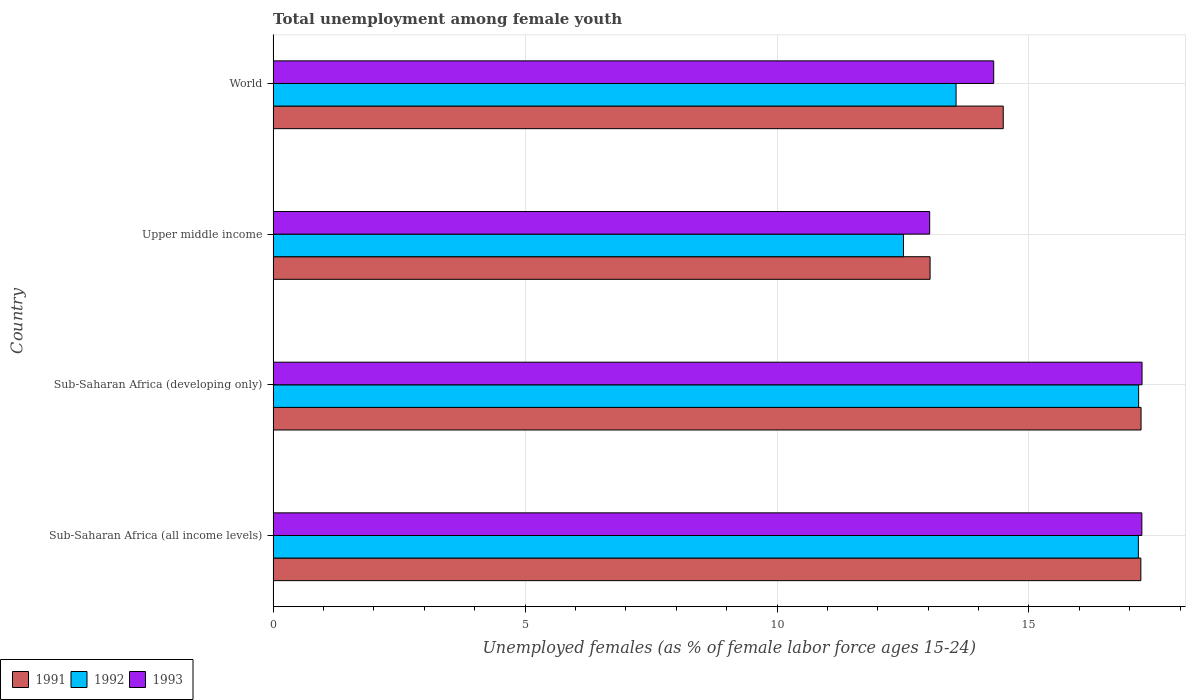How many bars are there on the 2nd tick from the bottom?
Keep it short and to the point. 3. What is the label of the 4th group of bars from the top?
Provide a short and direct response. Sub-Saharan Africa (all income levels). In how many cases, is the number of bars for a given country not equal to the number of legend labels?
Provide a short and direct response. 0. What is the percentage of unemployed females in in 1993 in Upper middle income?
Your answer should be compact. 13.03. Across all countries, what is the maximum percentage of unemployed females in in 1993?
Make the answer very short. 17.24. Across all countries, what is the minimum percentage of unemployed females in in 1991?
Provide a short and direct response. 13.04. In which country was the percentage of unemployed females in in 1993 maximum?
Offer a terse response. Sub-Saharan Africa (developing only). In which country was the percentage of unemployed females in in 1993 minimum?
Make the answer very short. Upper middle income. What is the total percentage of unemployed females in in 1993 in the graph?
Give a very brief answer. 61.81. What is the difference between the percentage of unemployed females in in 1991 in Sub-Saharan Africa (developing only) and that in Upper middle income?
Provide a short and direct response. 4.19. What is the difference between the percentage of unemployed females in in 1992 in Sub-Saharan Africa (developing only) and the percentage of unemployed females in in 1991 in World?
Keep it short and to the point. 2.69. What is the average percentage of unemployed females in in 1991 per country?
Make the answer very short. 15.49. What is the difference between the percentage of unemployed females in in 1993 and percentage of unemployed females in in 1991 in World?
Ensure brevity in your answer.  -0.19. In how many countries, is the percentage of unemployed females in in 1991 greater than 12 %?
Your response must be concise. 4. What is the ratio of the percentage of unemployed females in in 1991 in Sub-Saharan Africa (all income levels) to that in Sub-Saharan Africa (developing only)?
Your answer should be compact. 1. Is the difference between the percentage of unemployed females in in 1993 in Sub-Saharan Africa (developing only) and Upper middle income greater than the difference between the percentage of unemployed females in in 1991 in Sub-Saharan Africa (developing only) and Upper middle income?
Offer a very short reply. Yes. What is the difference between the highest and the second highest percentage of unemployed females in in 1992?
Your answer should be very brief. 0.01. What is the difference between the highest and the lowest percentage of unemployed females in in 1991?
Provide a succinct answer. 4.19. In how many countries, is the percentage of unemployed females in in 1991 greater than the average percentage of unemployed females in in 1991 taken over all countries?
Offer a very short reply. 2. Is the sum of the percentage of unemployed females in in 1992 in Sub-Saharan Africa (developing only) and World greater than the maximum percentage of unemployed females in in 1991 across all countries?
Your answer should be compact. Yes. What does the 1st bar from the bottom in Sub-Saharan Africa (developing only) represents?
Your response must be concise. 1991. Is it the case that in every country, the sum of the percentage of unemployed females in in 1992 and percentage of unemployed females in in 1993 is greater than the percentage of unemployed females in in 1991?
Make the answer very short. Yes. How many bars are there?
Provide a succinct answer. 12. Are all the bars in the graph horizontal?
Provide a succinct answer. Yes. Does the graph contain grids?
Provide a short and direct response. Yes. Where does the legend appear in the graph?
Your answer should be compact. Bottom left. What is the title of the graph?
Ensure brevity in your answer.  Total unemployment among female youth. What is the label or title of the X-axis?
Ensure brevity in your answer.  Unemployed females (as % of female labor force ages 15-24). What is the Unemployed females (as % of female labor force ages 15-24) of 1991 in Sub-Saharan Africa (all income levels)?
Keep it short and to the point. 17.22. What is the Unemployed females (as % of female labor force ages 15-24) of 1992 in Sub-Saharan Africa (all income levels)?
Offer a terse response. 17.17. What is the Unemployed females (as % of female labor force ages 15-24) in 1993 in Sub-Saharan Africa (all income levels)?
Your response must be concise. 17.24. What is the Unemployed females (as % of female labor force ages 15-24) in 1991 in Sub-Saharan Africa (developing only)?
Provide a short and direct response. 17.22. What is the Unemployed females (as % of female labor force ages 15-24) in 1992 in Sub-Saharan Africa (developing only)?
Make the answer very short. 17.18. What is the Unemployed females (as % of female labor force ages 15-24) of 1993 in Sub-Saharan Africa (developing only)?
Provide a succinct answer. 17.24. What is the Unemployed females (as % of female labor force ages 15-24) of 1991 in Upper middle income?
Provide a short and direct response. 13.04. What is the Unemployed females (as % of female labor force ages 15-24) of 1992 in Upper middle income?
Keep it short and to the point. 12.51. What is the Unemployed females (as % of female labor force ages 15-24) of 1993 in Upper middle income?
Make the answer very short. 13.03. What is the Unemployed females (as % of female labor force ages 15-24) in 1991 in World?
Give a very brief answer. 14.49. What is the Unemployed females (as % of female labor force ages 15-24) in 1992 in World?
Provide a succinct answer. 13.55. What is the Unemployed females (as % of female labor force ages 15-24) of 1993 in World?
Make the answer very short. 14.3. Across all countries, what is the maximum Unemployed females (as % of female labor force ages 15-24) in 1991?
Your answer should be very brief. 17.22. Across all countries, what is the maximum Unemployed females (as % of female labor force ages 15-24) of 1992?
Provide a short and direct response. 17.18. Across all countries, what is the maximum Unemployed females (as % of female labor force ages 15-24) of 1993?
Your response must be concise. 17.24. Across all countries, what is the minimum Unemployed females (as % of female labor force ages 15-24) in 1991?
Your answer should be compact. 13.04. Across all countries, what is the minimum Unemployed females (as % of female labor force ages 15-24) of 1992?
Your answer should be very brief. 12.51. Across all countries, what is the minimum Unemployed females (as % of female labor force ages 15-24) in 1993?
Ensure brevity in your answer.  13.03. What is the total Unemployed females (as % of female labor force ages 15-24) in 1991 in the graph?
Offer a very short reply. 61.97. What is the total Unemployed females (as % of female labor force ages 15-24) in 1992 in the graph?
Provide a short and direct response. 60.41. What is the total Unemployed females (as % of female labor force ages 15-24) in 1993 in the graph?
Your answer should be very brief. 61.81. What is the difference between the Unemployed females (as % of female labor force ages 15-24) of 1991 in Sub-Saharan Africa (all income levels) and that in Sub-Saharan Africa (developing only)?
Give a very brief answer. -0. What is the difference between the Unemployed females (as % of female labor force ages 15-24) in 1992 in Sub-Saharan Africa (all income levels) and that in Sub-Saharan Africa (developing only)?
Your answer should be compact. -0.01. What is the difference between the Unemployed females (as % of female labor force ages 15-24) in 1993 in Sub-Saharan Africa (all income levels) and that in Sub-Saharan Africa (developing only)?
Offer a very short reply. -0. What is the difference between the Unemployed females (as % of female labor force ages 15-24) of 1991 in Sub-Saharan Africa (all income levels) and that in Upper middle income?
Provide a short and direct response. 4.18. What is the difference between the Unemployed females (as % of female labor force ages 15-24) of 1992 in Sub-Saharan Africa (all income levels) and that in Upper middle income?
Provide a short and direct response. 4.66. What is the difference between the Unemployed females (as % of female labor force ages 15-24) of 1993 in Sub-Saharan Africa (all income levels) and that in Upper middle income?
Provide a succinct answer. 4.21. What is the difference between the Unemployed females (as % of female labor force ages 15-24) in 1991 in Sub-Saharan Africa (all income levels) and that in World?
Offer a very short reply. 2.73. What is the difference between the Unemployed females (as % of female labor force ages 15-24) of 1992 in Sub-Saharan Africa (all income levels) and that in World?
Your answer should be very brief. 3.62. What is the difference between the Unemployed females (as % of female labor force ages 15-24) in 1993 in Sub-Saharan Africa (all income levels) and that in World?
Offer a very short reply. 2.94. What is the difference between the Unemployed females (as % of female labor force ages 15-24) in 1991 in Sub-Saharan Africa (developing only) and that in Upper middle income?
Provide a succinct answer. 4.19. What is the difference between the Unemployed females (as % of female labor force ages 15-24) in 1992 in Sub-Saharan Africa (developing only) and that in Upper middle income?
Provide a short and direct response. 4.67. What is the difference between the Unemployed females (as % of female labor force ages 15-24) in 1993 in Sub-Saharan Africa (developing only) and that in Upper middle income?
Provide a succinct answer. 4.21. What is the difference between the Unemployed females (as % of female labor force ages 15-24) in 1991 in Sub-Saharan Africa (developing only) and that in World?
Your answer should be compact. 2.73. What is the difference between the Unemployed females (as % of female labor force ages 15-24) in 1992 in Sub-Saharan Africa (developing only) and that in World?
Your response must be concise. 3.62. What is the difference between the Unemployed females (as % of female labor force ages 15-24) in 1993 in Sub-Saharan Africa (developing only) and that in World?
Your response must be concise. 2.94. What is the difference between the Unemployed females (as % of female labor force ages 15-24) in 1991 in Upper middle income and that in World?
Your response must be concise. -1.45. What is the difference between the Unemployed females (as % of female labor force ages 15-24) of 1992 in Upper middle income and that in World?
Keep it short and to the point. -1.04. What is the difference between the Unemployed females (as % of female labor force ages 15-24) of 1993 in Upper middle income and that in World?
Ensure brevity in your answer.  -1.27. What is the difference between the Unemployed females (as % of female labor force ages 15-24) of 1991 in Sub-Saharan Africa (all income levels) and the Unemployed females (as % of female labor force ages 15-24) of 1992 in Sub-Saharan Africa (developing only)?
Make the answer very short. 0.04. What is the difference between the Unemployed females (as % of female labor force ages 15-24) in 1991 in Sub-Saharan Africa (all income levels) and the Unemployed females (as % of female labor force ages 15-24) in 1993 in Sub-Saharan Africa (developing only)?
Give a very brief answer. -0.02. What is the difference between the Unemployed females (as % of female labor force ages 15-24) of 1992 in Sub-Saharan Africa (all income levels) and the Unemployed females (as % of female labor force ages 15-24) of 1993 in Sub-Saharan Africa (developing only)?
Your answer should be very brief. -0.07. What is the difference between the Unemployed females (as % of female labor force ages 15-24) in 1991 in Sub-Saharan Africa (all income levels) and the Unemployed females (as % of female labor force ages 15-24) in 1992 in Upper middle income?
Keep it short and to the point. 4.71. What is the difference between the Unemployed females (as % of female labor force ages 15-24) of 1991 in Sub-Saharan Africa (all income levels) and the Unemployed females (as % of female labor force ages 15-24) of 1993 in Upper middle income?
Provide a short and direct response. 4.19. What is the difference between the Unemployed females (as % of female labor force ages 15-24) of 1992 in Sub-Saharan Africa (all income levels) and the Unemployed females (as % of female labor force ages 15-24) of 1993 in Upper middle income?
Your answer should be compact. 4.14. What is the difference between the Unemployed females (as % of female labor force ages 15-24) in 1991 in Sub-Saharan Africa (all income levels) and the Unemployed females (as % of female labor force ages 15-24) in 1992 in World?
Provide a succinct answer. 3.67. What is the difference between the Unemployed females (as % of female labor force ages 15-24) of 1991 in Sub-Saharan Africa (all income levels) and the Unemployed females (as % of female labor force ages 15-24) of 1993 in World?
Your answer should be very brief. 2.92. What is the difference between the Unemployed females (as % of female labor force ages 15-24) of 1992 in Sub-Saharan Africa (all income levels) and the Unemployed females (as % of female labor force ages 15-24) of 1993 in World?
Offer a very short reply. 2.87. What is the difference between the Unemployed females (as % of female labor force ages 15-24) in 1991 in Sub-Saharan Africa (developing only) and the Unemployed females (as % of female labor force ages 15-24) in 1992 in Upper middle income?
Provide a short and direct response. 4.71. What is the difference between the Unemployed females (as % of female labor force ages 15-24) in 1991 in Sub-Saharan Africa (developing only) and the Unemployed females (as % of female labor force ages 15-24) in 1993 in Upper middle income?
Offer a very short reply. 4.19. What is the difference between the Unemployed females (as % of female labor force ages 15-24) of 1992 in Sub-Saharan Africa (developing only) and the Unemployed females (as % of female labor force ages 15-24) of 1993 in Upper middle income?
Your response must be concise. 4.15. What is the difference between the Unemployed females (as % of female labor force ages 15-24) of 1991 in Sub-Saharan Africa (developing only) and the Unemployed females (as % of female labor force ages 15-24) of 1992 in World?
Offer a terse response. 3.67. What is the difference between the Unemployed females (as % of female labor force ages 15-24) of 1991 in Sub-Saharan Africa (developing only) and the Unemployed females (as % of female labor force ages 15-24) of 1993 in World?
Give a very brief answer. 2.92. What is the difference between the Unemployed females (as % of female labor force ages 15-24) in 1992 in Sub-Saharan Africa (developing only) and the Unemployed females (as % of female labor force ages 15-24) in 1993 in World?
Your response must be concise. 2.88. What is the difference between the Unemployed females (as % of female labor force ages 15-24) in 1991 in Upper middle income and the Unemployed females (as % of female labor force ages 15-24) in 1992 in World?
Keep it short and to the point. -0.52. What is the difference between the Unemployed females (as % of female labor force ages 15-24) of 1991 in Upper middle income and the Unemployed females (as % of female labor force ages 15-24) of 1993 in World?
Offer a terse response. -1.26. What is the difference between the Unemployed females (as % of female labor force ages 15-24) in 1992 in Upper middle income and the Unemployed females (as % of female labor force ages 15-24) in 1993 in World?
Provide a short and direct response. -1.79. What is the average Unemployed females (as % of female labor force ages 15-24) of 1991 per country?
Ensure brevity in your answer.  15.49. What is the average Unemployed females (as % of female labor force ages 15-24) in 1992 per country?
Keep it short and to the point. 15.1. What is the average Unemployed females (as % of female labor force ages 15-24) of 1993 per country?
Provide a short and direct response. 15.45. What is the difference between the Unemployed females (as % of female labor force ages 15-24) of 1991 and Unemployed females (as % of female labor force ages 15-24) of 1992 in Sub-Saharan Africa (all income levels)?
Give a very brief answer. 0.05. What is the difference between the Unemployed females (as % of female labor force ages 15-24) of 1991 and Unemployed females (as % of female labor force ages 15-24) of 1993 in Sub-Saharan Africa (all income levels)?
Your answer should be very brief. -0.02. What is the difference between the Unemployed females (as % of female labor force ages 15-24) in 1992 and Unemployed females (as % of female labor force ages 15-24) in 1993 in Sub-Saharan Africa (all income levels)?
Ensure brevity in your answer.  -0.07. What is the difference between the Unemployed females (as % of female labor force ages 15-24) of 1991 and Unemployed females (as % of female labor force ages 15-24) of 1992 in Sub-Saharan Africa (developing only)?
Provide a succinct answer. 0.05. What is the difference between the Unemployed females (as % of female labor force ages 15-24) of 1991 and Unemployed females (as % of female labor force ages 15-24) of 1993 in Sub-Saharan Africa (developing only)?
Ensure brevity in your answer.  -0.02. What is the difference between the Unemployed females (as % of female labor force ages 15-24) in 1992 and Unemployed females (as % of female labor force ages 15-24) in 1993 in Sub-Saharan Africa (developing only)?
Make the answer very short. -0.07. What is the difference between the Unemployed females (as % of female labor force ages 15-24) in 1991 and Unemployed females (as % of female labor force ages 15-24) in 1992 in Upper middle income?
Provide a short and direct response. 0.53. What is the difference between the Unemployed females (as % of female labor force ages 15-24) in 1991 and Unemployed females (as % of female labor force ages 15-24) in 1993 in Upper middle income?
Make the answer very short. 0.01. What is the difference between the Unemployed females (as % of female labor force ages 15-24) of 1992 and Unemployed females (as % of female labor force ages 15-24) of 1993 in Upper middle income?
Offer a very short reply. -0.52. What is the difference between the Unemployed females (as % of female labor force ages 15-24) in 1991 and Unemployed females (as % of female labor force ages 15-24) in 1992 in World?
Make the answer very short. 0.94. What is the difference between the Unemployed females (as % of female labor force ages 15-24) of 1991 and Unemployed females (as % of female labor force ages 15-24) of 1993 in World?
Your answer should be compact. 0.19. What is the difference between the Unemployed females (as % of female labor force ages 15-24) of 1992 and Unemployed females (as % of female labor force ages 15-24) of 1993 in World?
Make the answer very short. -0.75. What is the ratio of the Unemployed females (as % of female labor force ages 15-24) of 1993 in Sub-Saharan Africa (all income levels) to that in Sub-Saharan Africa (developing only)?
Ensure brevity in your answer.  1. What is the ratio of the Unemployed females (as % of female labor force ages 15-24) in 1991 in Sub-Saharan Africa (all income levels) to that in Upper middle income?
Provide a short and direct response. 1.32. What is the ratio of the Unemployed females (as % of female labor force ages 15-24) of 1992 in Sub-Saharan Africa (all income levels) to that in Upper middle income?
Provide a succinct answer. 1.37. What is the ratio of the Unemployed females (as % of female labor force ages 15-24) of 1993 in Sub-Saharan Africa (all income levels) to that in Upper middle income?
Offer a terse response. 1.32. What is the ratio of the Unemployed females (as % of female labor force ages 15-24) of 1991 in Sub-Saharan Africa (all income levels) to that in World?
Your answer should be compact. 1.19. What is the ratio of the Unemployed females (as % of female labor force ages 15-24) of 1992 in Sub-Saharan Africa (all income levels) to that in World?
Your answer should be compact. 1.27. What is the ratio of the Unemployed females (as % of female labor force ages 15-24) of 1993 in Sub-Saharan Africa (all income levels) to that in World?
Provide a short and direct response. 1.21. What is the ratio of the Unemployed females (as % of female labor force ages 15-24) in 1991 in Sub-Saharan Africa (developing only) to that in Upper middle income?
Your response must be concise. 1.32. What is the ratio of the Unemployed females (as % of female labor force ages 15-24) of 1992 in Sub-Saharan Africa (developing only) to that in Upper middle income?
Offer a terse response. 1.37. What is the ratio of the Unemployed females (as % of female labor force ages 15-24) in 1993 in Sub-Saharan Africa (developing only) to that in Upper middle income?
Ensure brevity in your answer.  1.32. What is the ratio of the Unemployed females (as % of female labor force ages 15-24) of 1991 in Sub-Saharan Africa (developing only) to that in World?
Provide a succinct answer. 1.19. What is the ratio of the Unemployed females (as % of female labor force ages 15-24) in 1992 in Sub-Saharan Africa (developing only) to that in World?
Your response must be concise. 1.27. What is the ratio of the Unemployed females (as % of female labor force ages 15-24) in 1993 in Sub-Saharan Africa (developing only) to that in World?
Give a very brief answer. 1.21. What is the ratio of the Unemployed females (as % of female labor force ages 15-24) of 1991 in Upper middle income to that in World?
Make the answer very short. 0.9. What is the ratio of the Unemployed females (as % of female labor force ages 15-24) of 1992 in Upper middle income to that in World?
Ensure brevity in your answer.  0.92. What is the ratio of the Unemployed females (as % of female labor force ages 15-24) in 1993 in Upper middle income to that in World?
Offer a very short reply. 0.91. What is the difference between the highest and the second highest Unemployed females (as % of female labor force ages 15-24) in 1991?
Offer a very short reply. 0. What is the difference between the highest and the second highest Unemployed females (as % of female labor force ages 15-24) of 1992?
Make the answer very short. 0.01. What is the difference between the highest and the second highest Unemployed females (as % of female labor force ages 15-24) of 1993?
Provide a succinct answer. 0. What is the difference between the highest and the lowest Unemployed females (as % of female labor force ages 15-24) in 1991?
Keep it short and to the point. 4.19. What is the difference between the highest and the lowest Unemployed females (as % of female labor force ages 15-24) in 1992?
Keep it short and to the point. 4.67. What is the difference between the highest and the lowest Unemployed females (as % of female labor force ages 15-24) of 1993?
Provide a succinct answer. 4.21. 